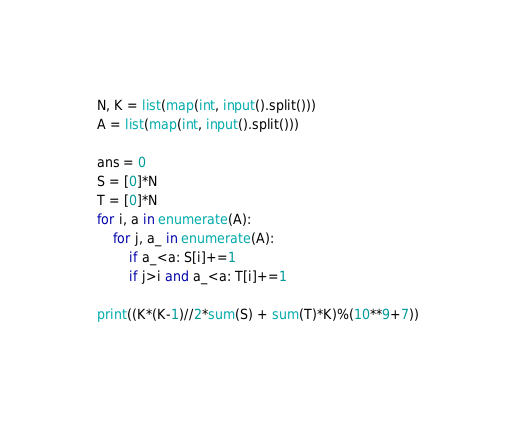Convert code to text. <code><loc_0><loc_0><loc_500><loc_500><_Python_>N, K = list(map(int, input().split()))
A = list(map(int, input().split()))

ans = 0
S = [0]*N
T = [0]*N
for i, a in enumerate(A):
    for j, a_ in enumerate(A):
        if a_<a: S[i]+=1
        if j>i and a_<a: T[i]+=1

print((K*(K-1)//2*sum(S) + sum(T)*K)%(10**9+7))</code> 